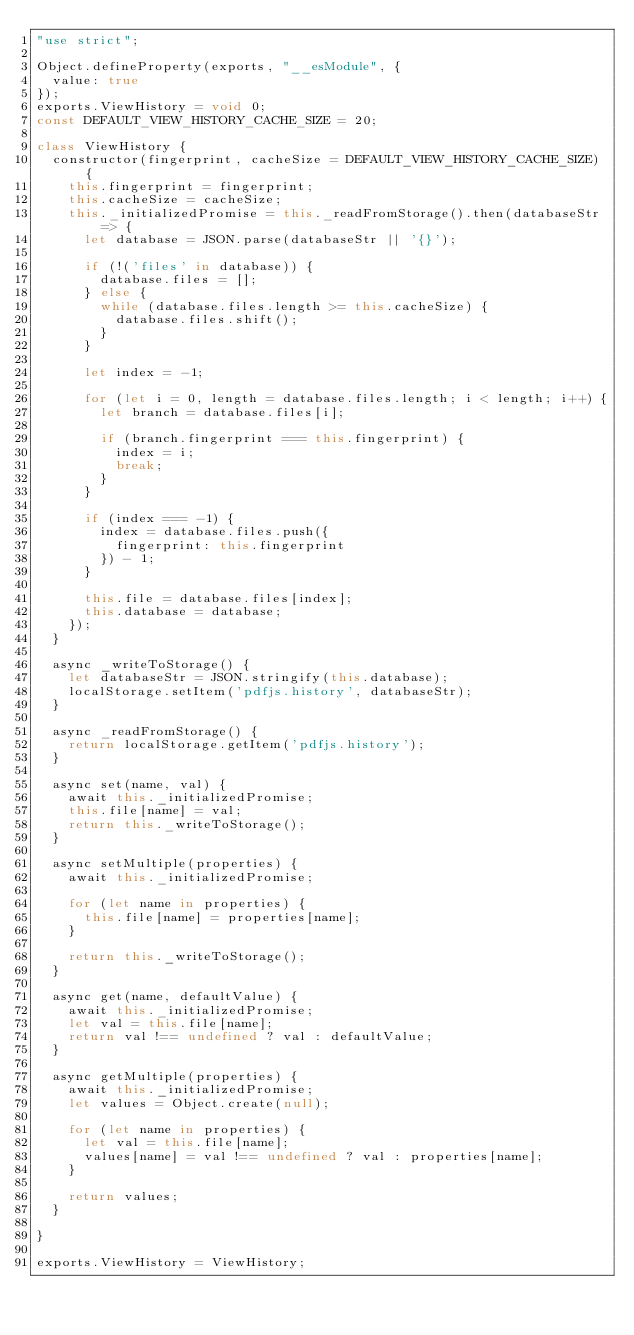<code> <loc_0><loc_0><loc_500><loc_500><_JavaScript_>"use strict";

Object.defineProperty(exports, "__esModule", {
  value: true
});
exports.ViewHistory = void 0;
const DEFAULT_VIEW_HISTORY_CACHE_SIZE = 20;

class ViewHistory {
  constructor(fingerprint, cacheSize = DEFAULT_VIEW_HISTORY_CACHE_SIZE) {
    this.fingerprint = fingerprint;
    this.cacheSize = cacheSize;
    this._initializedPromise = this._readFromStorage().then(databaseStr => {
      let database = JSON.parse(databaseStr || '{}');

      if (!('files' in database)) {
        database.files = [];
      } else {
        while (database.files.length >= this.cacheSize) {
          database.files.shift();
        }
      }

      let index = -1;

      for (let i = 0, length = database.files.length; i < length; i++) {
        let branch = database.files[i];

        if (branch.fingerprint === this.fingerprint) {
          index = i;
          break;
        }
      }

      if (index === -1) {
        index = database.files.push({
          fingerprint: this.fingerprint
        }) - 1;
      }

      this.file = database.files[index];
      this.database = database;
    });
  }

  async _writeToStorage() {
    let databaseStr = JSON.stringify(this.database);
    localStorage.setItem('pdfjs.history', databaseStr);
  }

  async _readFromStorage() {
    return localStorage.getItem('pdfjs.history');
  }

  async set(name, val) {
    await this._initializedPromise;
    this.file[name] = val;
    return this._writeToStorage();
  }

  async setMultiple(properties) {
    await this._initializedPromise;

    for (let name in properties) {
      this.file[name] = properties[name];
    }

    return this._writeToStorage();
  }

  async get(name, defaultValue) {
    await this._initializedPromise;
    let val = this.file[name];
    return val !== undefined ? val : defaultValue;
  }

  async getMultiple(properties) {
    await this._initializedPromise;
    let values = Object.create(null);

    for (let name in properties) {
      let val = this.file[name];
      values[name] = val !== undefined ? val : properties[name];
    }

    return values;
  }

}

exports.ViewHistory = ViewHistory;</code> 